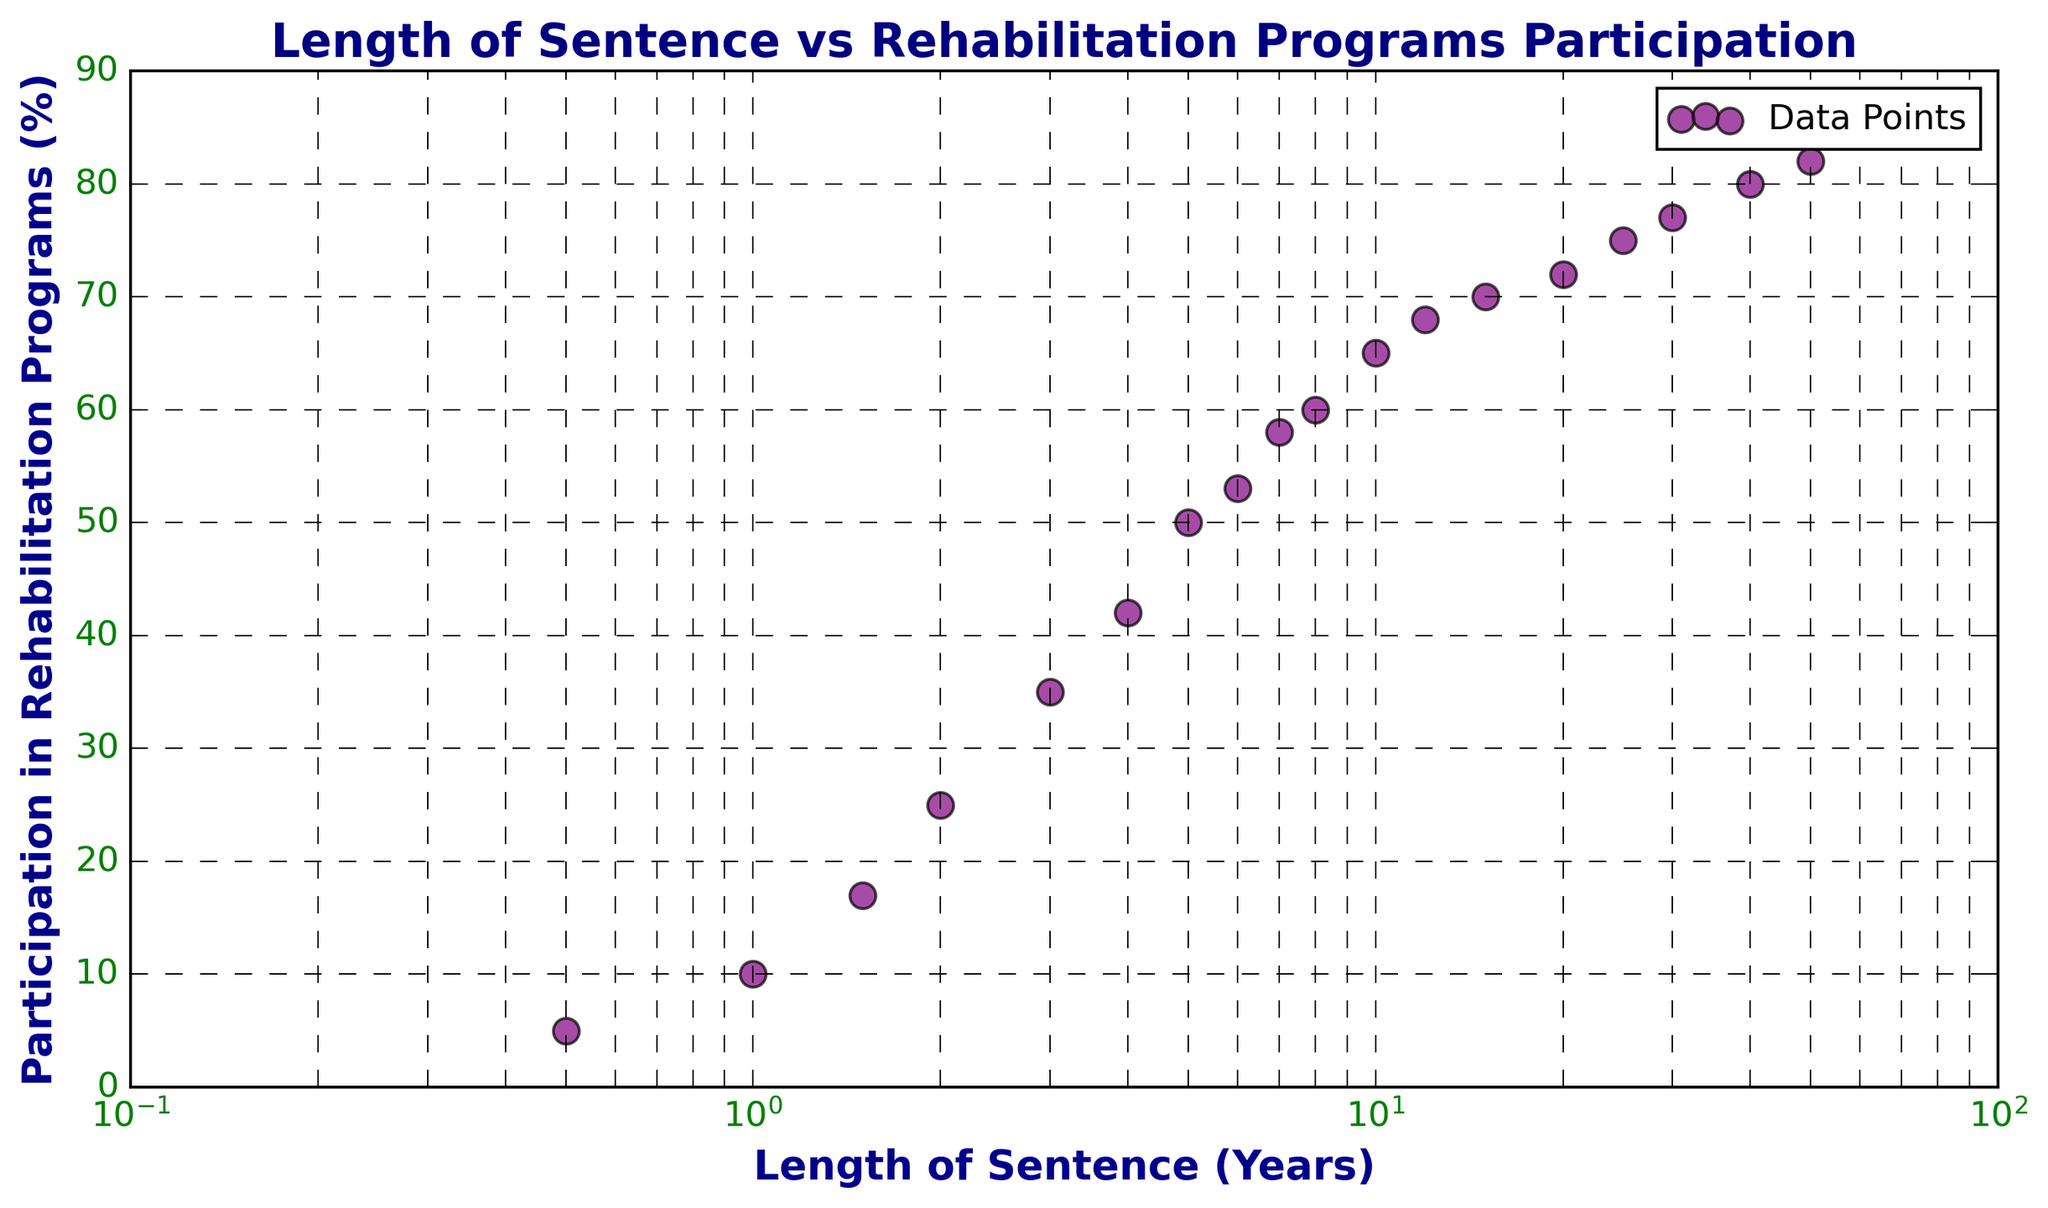What's the range of participation in rehabilitation programs for sentences between 1 and 10 years? To find the range, identify the minimum and maximum participation rates within the specified sentence length. For sentences between 1 and 10 years, the rates range from 10% to 65%. Subtract the minimum from the maximum: 65% - 10% = 55%.
Answer: 55% Is the participation in rehabilitation programs for sentences of 6 years higher or lower than for 4 years? Examine the plotted data points for sentences of 4 years and 6 years. The participation rate at 4 years is 42%, and at 6 years, it is 53%. Since 53% is greater than 42%, participation for 6 years is higher.
Answer: Higher Which sentence length shows the greatest increase in participation rates, comparing 1-year and 1.5 years or 2 years and 2.5 years? To determine the increase, calculate the difference in participation rates for each interval. For 1 year to 1.5 years: 17% - 10% = 7%. For 2 years to 2.5 years, there's no data at 2.5 years, thus check between 2-3: 35% - 25% = 10%. Clearly, 35% - 25% = 10% shows the greater increase.
Answer: 2 to 3 years Based on the trend shown in the plot, does participation in rehabilitation programs significantly increase after a certain length of sentence? Observe the overall trend: there is a noticeable increase in participation as the sentence length grows, particularly between 1 year and 10 years, where the participation rises consistently. Beyond 10 years, the rate of increase slows but continues upward.
Answer: Yes, especially between 1 and 10 years What is the participation rate in rehabilitation programs for a sentence of 20 years? Locate the data point corresponding to 20 years on the x-axis and read its y-axis value. The participation rate for 20 years is 72%.
Answer: 72% Do sentences of 5 years have higher or lower participation compared to sentences of 8 years? Compare the rates for 5 and 8 years as shown on the plot. At 5 years, the rate is 50%; at 8 years, it is 60%. Since 60% is greater than 50%, participation is higher at 8 years.
Answer: Higher How does the participation rate change from 10 to 50 years of sentences? Identify the participation rates for 10 and 50 years, 65% and 82% respectively. Calculate the difference: 82% - 65% = 17%. Participation increases by 17% over this period.
Answer: Increases by 17% Which sentence length shows a participation rate of around 77%? Find the data point close to 77% on the y-axis and trace it to its corresponding x-axis value. The sentence length near 77% participation is approximately 30 years.
Answer: 30 years What is the average participation rate for sentence lengths of 1, 1.5, and 2 years? Calculate the average of the given participation rates: (10% + 17% + 25%)/3. Sum these rates: 10% + 17% + 25% = 52%. Divide by 3: 52%/3 ≈ 17.33%.
Answer: 17.33% Is there a noticeable trend in the data with the log scale used on the x-axis? Examine the plot to see how the points align. On a log scale, the trend becomes more pronounced: we see an initial sharp increase in participation with short sentences which then gradually levels off.
Answer: Yes, it shows a sharp initial increase and then gradual leveling off 